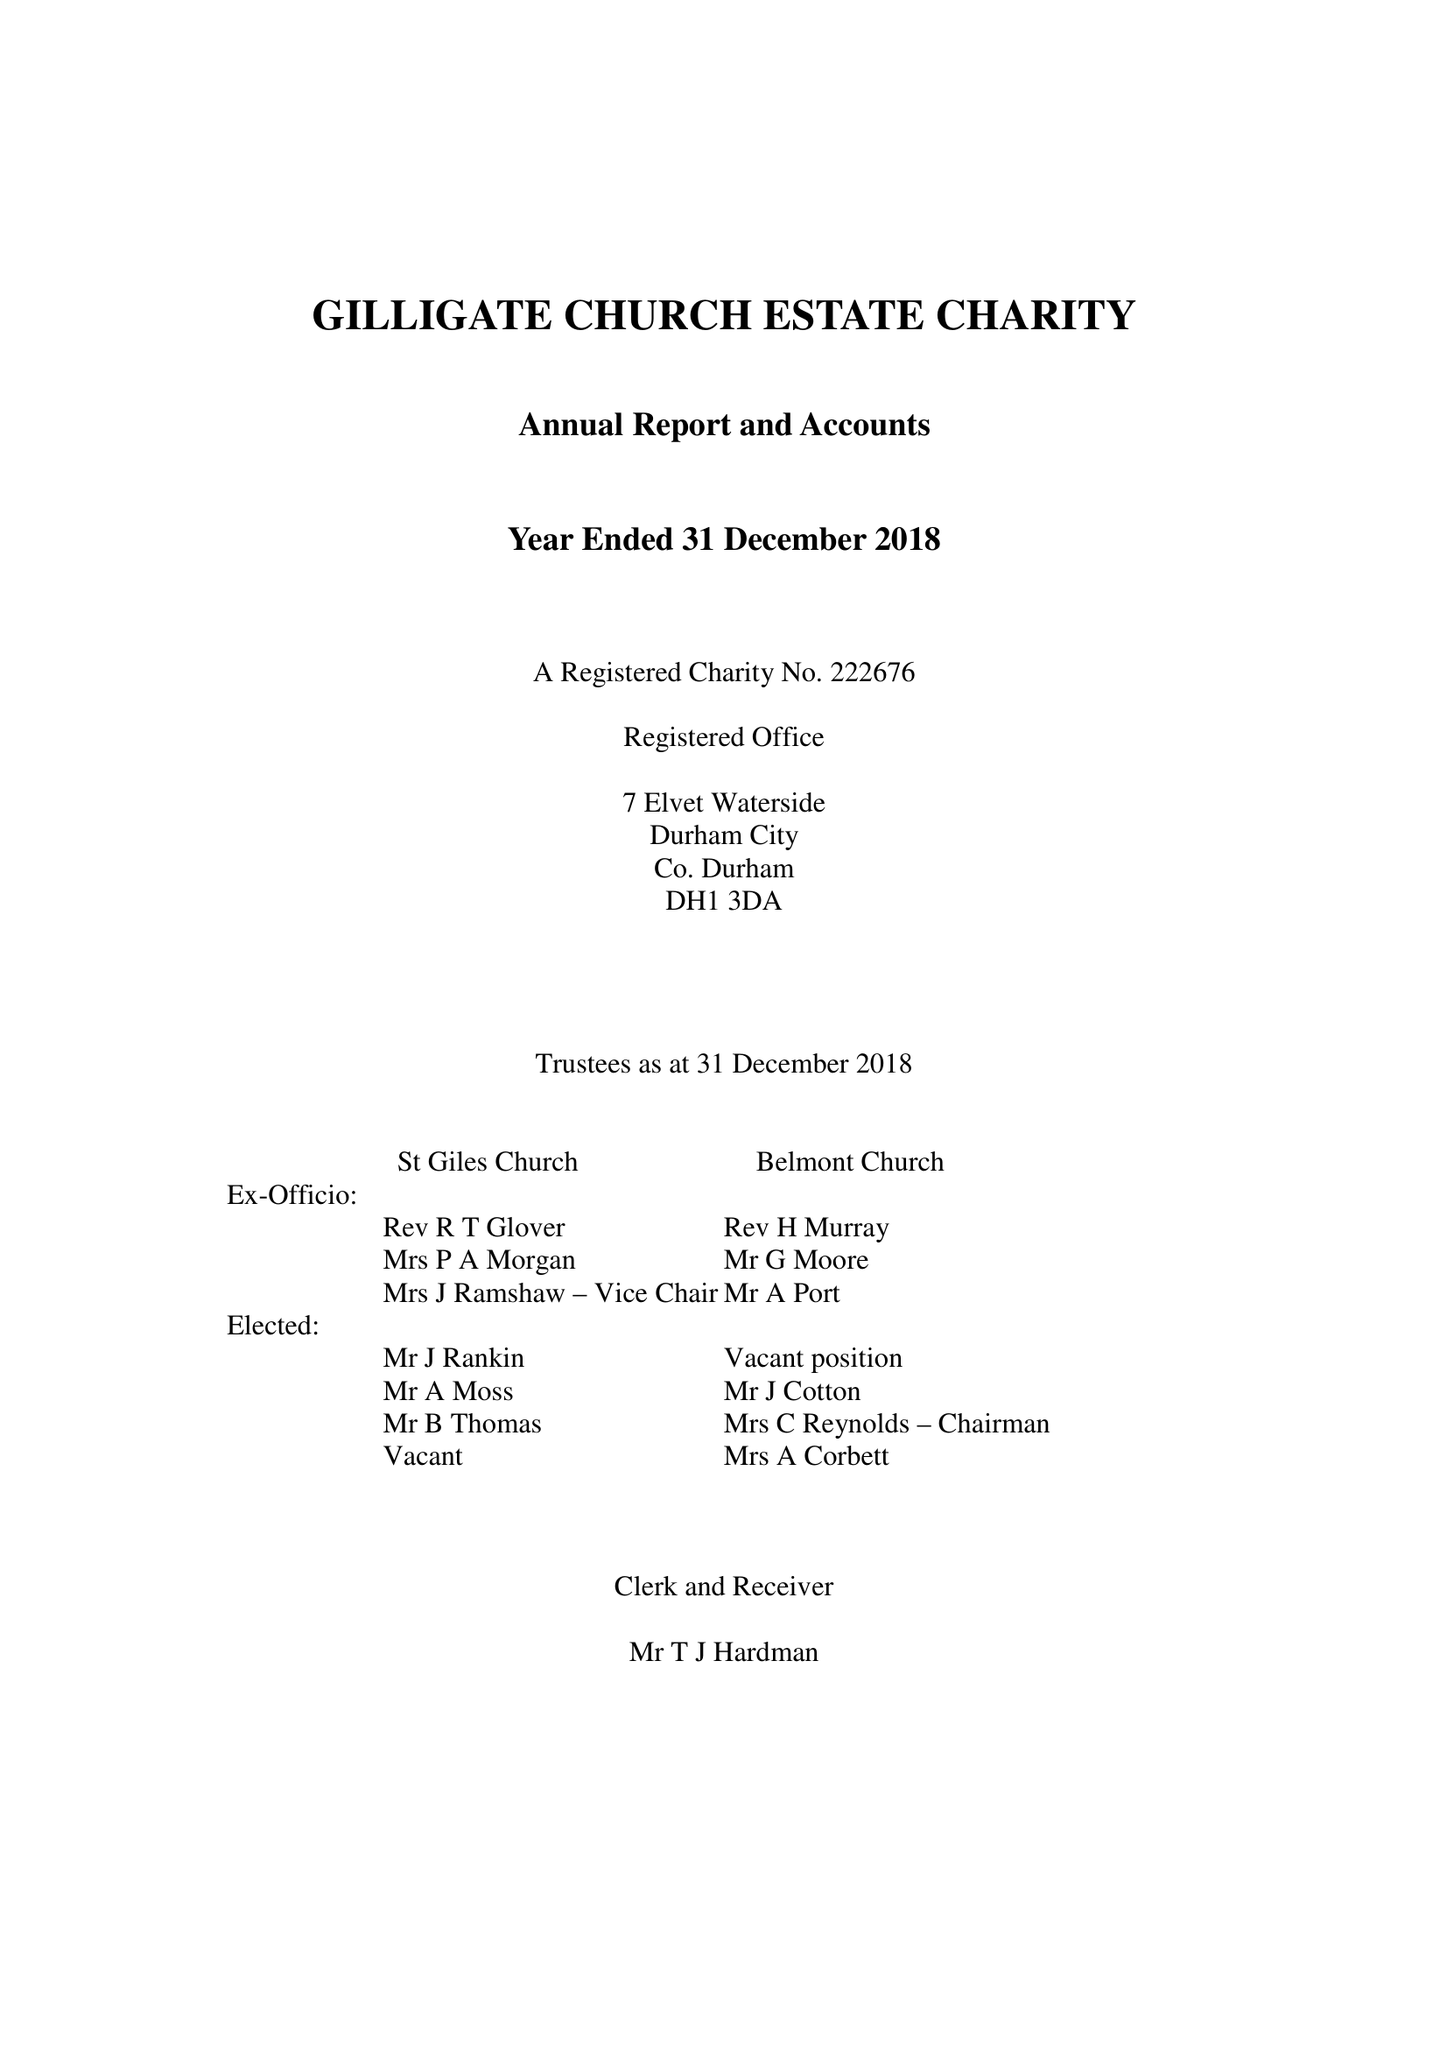What is the value for the spending_annually_in_british_pounds?
Answer the question using a single word or phrase. 90855.00 